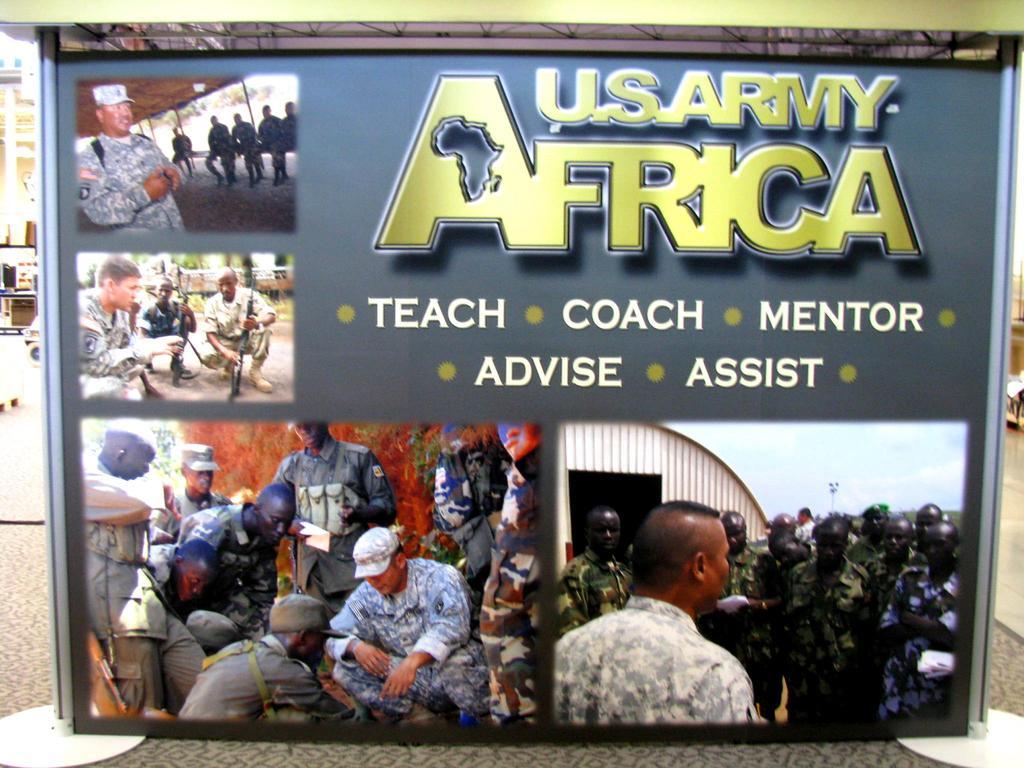Please provide a concise description of this image. In the image there is a poster. At the top right of the poster there is something written on it. And on the poster there are few images. In the image there are men with uniforms, caps and holding guns. 